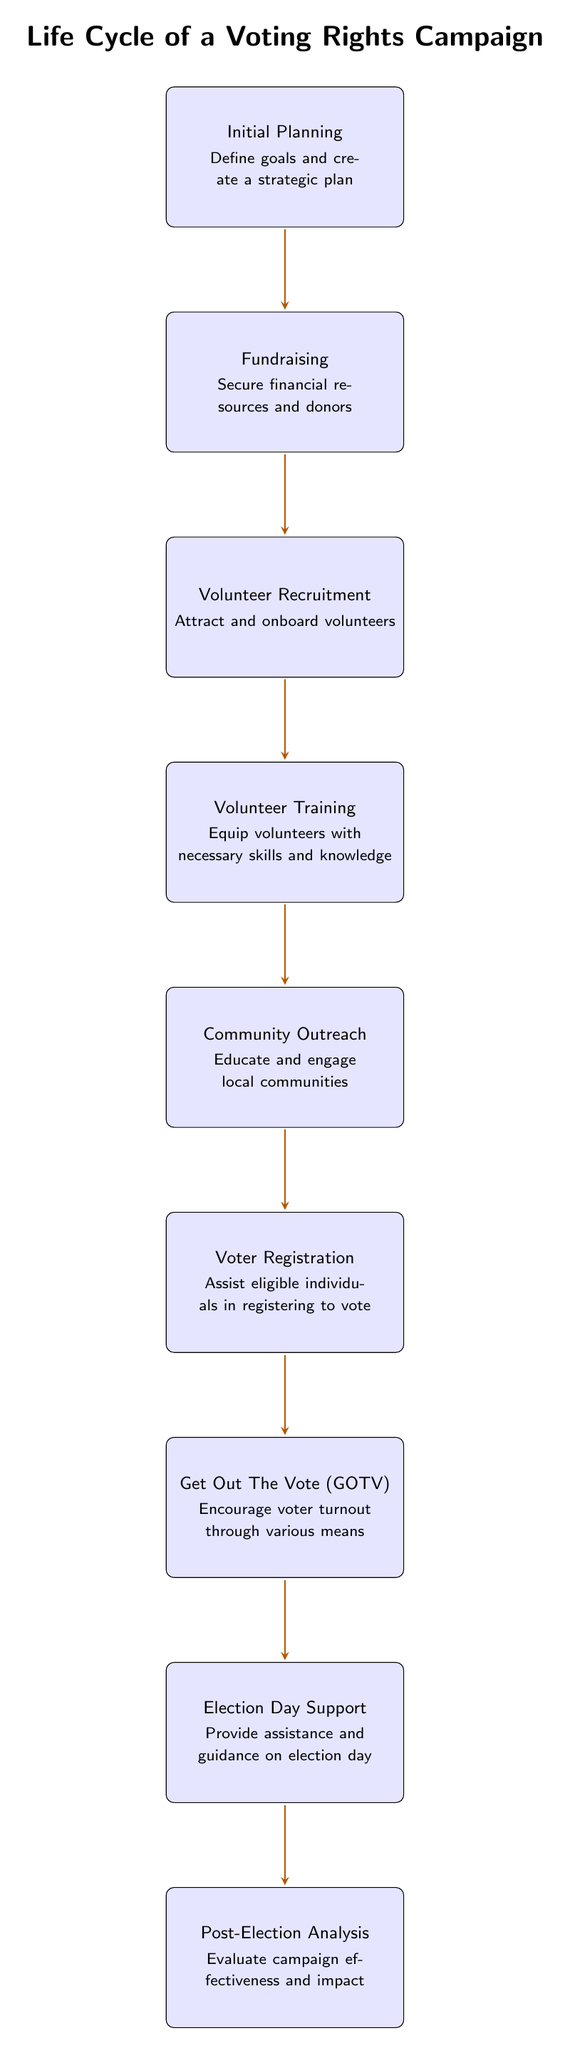What is the first step in the life cycle of a voting rights campaign? The diagram lists "Initial Planning" as the first node at the top, indicating that it is the starting point of the process in the life cycle of a voting rights campaign.
Answer: Initial Planning How many steps are there in the life cycle of a voting rights campaign? By counting the number of nodes in the diagram, there are a total of eight steps depicted leading from "Initial Planning" down to "Post-Election Analysis."
Answer: Eight What node directly follows volunteer training in the diagram? The arrow indicates that the next step after "Volunteer Training" is "Community Outreach," demonstrating the sequential flow of the campaign activities.
Answer: Community Outreach What is the purpose of the "Get Out The Vote (GOTV)" phase? The diagram specifies that the purpose of this phase is to "Encourage voter turnout through various means," directly summarizing its main goal as described in the node.
Answer: Encourage voter turnout What relationship exists between "Fundraising" and "Volunteer Recruitment"? There is a directed arrow from "Fundraising" to "Volunteer Recruitment," indicating that fundraising activities influence or lead into the recruitment process for volunteers.
Answer: Leads to What is the last phase in the life cycle of a voting rights campaign? The diagram shows that "Post-Election Analysis" is at the bottom, which means it is the concluding step of the entire life cycle, focusing on evaluating the campaign's effectiveness.
Answer: Post-Election Analysis How does the "Voter Registration" phase relate to "Community Outreach"? There is a direct flow with an arrow going from "Community Outreach" to "Voter Registration," indicating that outreach efforts aim to facilitate voter registration as a follow-up activity.
Answer: Facilitates voter registration What does the "Election Day Support" phase provide? The node explains that this phase is designated to "Provide assistance and guidance on election day," summarizing the supportive role this phase plays during the election process.
Answer: Assistance and guidance 